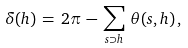<formula> <loc_0><loc_0><loc_500><loc_500>\delta ( h ) \, = \, 2 \pi \, - \, \sum _ { s \supset h } \, \theta ( s , h ) \, ,</formula> 